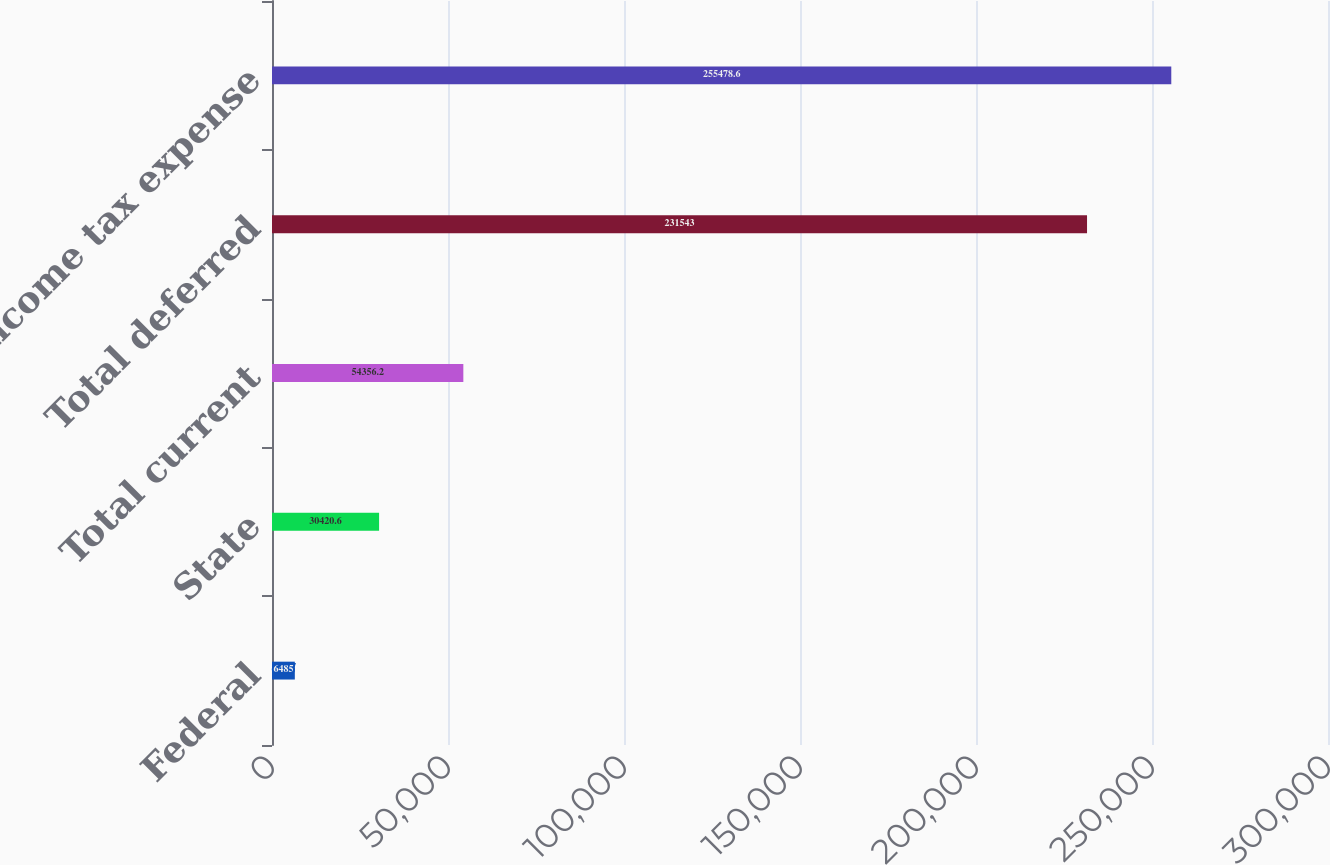Convert chart. <chart><loc_0><loc_0><loc_500><loc_500><bar_chart><fcel>Federal<fcel>State<fcel>Total current<fcel>Total deferred<fcel>Income tax expense<nl><fcel>6485<fcel>30420.6<fcel>54356.2<fcel>231543<fcel>255479<nl></chart> 